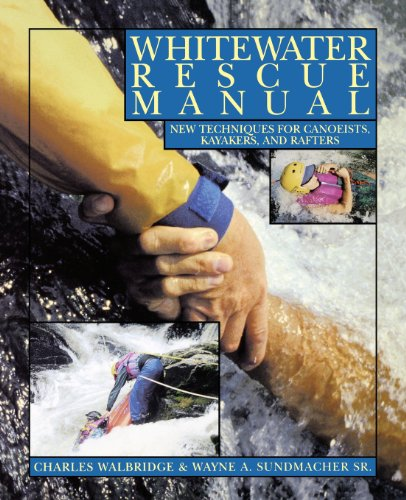What is the title of this book? The title of the book is 'Whitewater Rescue Manual: New Techniques for Canoeists, Kayakers, and Rafters' - a comprehensive guide for water sports enthusiasts. 